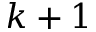<formula> <loc_0><loc_0><loc_500><loc_500>k + 1</formula> 